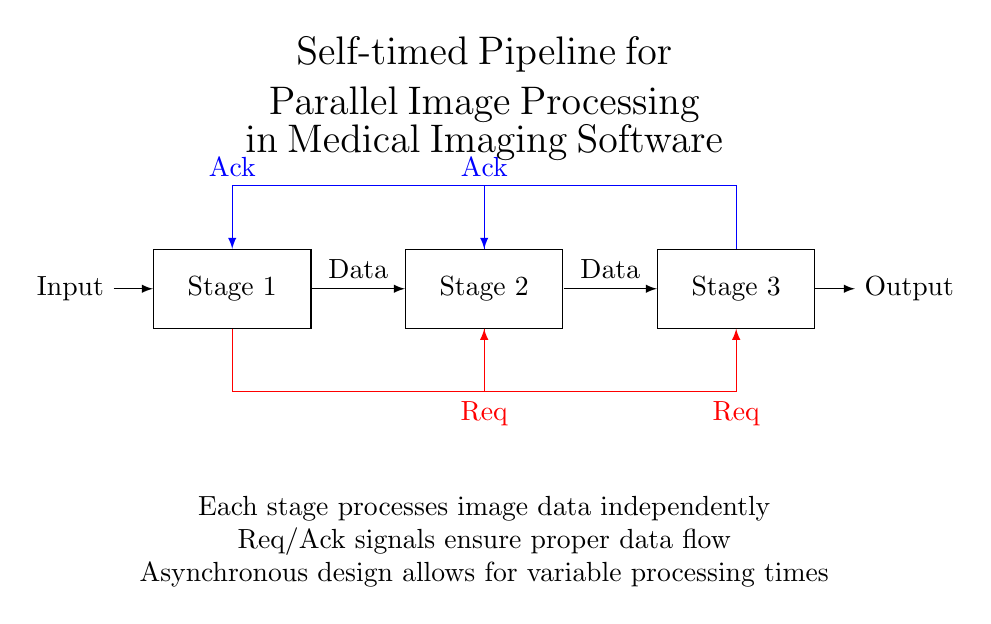What are the stages in this pipeline? The diagram presents three distinct stages labeled Stage 1, Stage 2, and Stage 3, indicating a sequential flow of processing.
Answer: Stage 1, Stage 2, Stage 3 What is the purpose of the Req signals? Req signals are used to request the processing of data from one stage to the subsequent stage, ensuring that data flow occurs in an organized manner.
Answer: Request What does the Ack signal signify? The Ack signal indicates that a stage has successfully processed the incoming data and is ready to acknowledge receipt of the data.
Answer: Acknowledge How many total data flow connections are visible? There are two connections shown between the stages, each representing the flow of data from one stage to the next.
Answer: Two Which color is used to represent the Req signals? The Req signals are represented using the color red in the diagram, helping to distinguish them from other signals.
Answer: Red What does asynchronous design allow regarding processing times? The asynchronous design allows for variable processing times, enabling stages to operate independently without waiting for others to complete.
Answer: Variable processing times How does the self-timed pipeline improve image processing? The self-timed pipeline allows each stage to process image data independently and handle differing processing times, enhancing overall efficiency.
Answer: Improved efficiency 